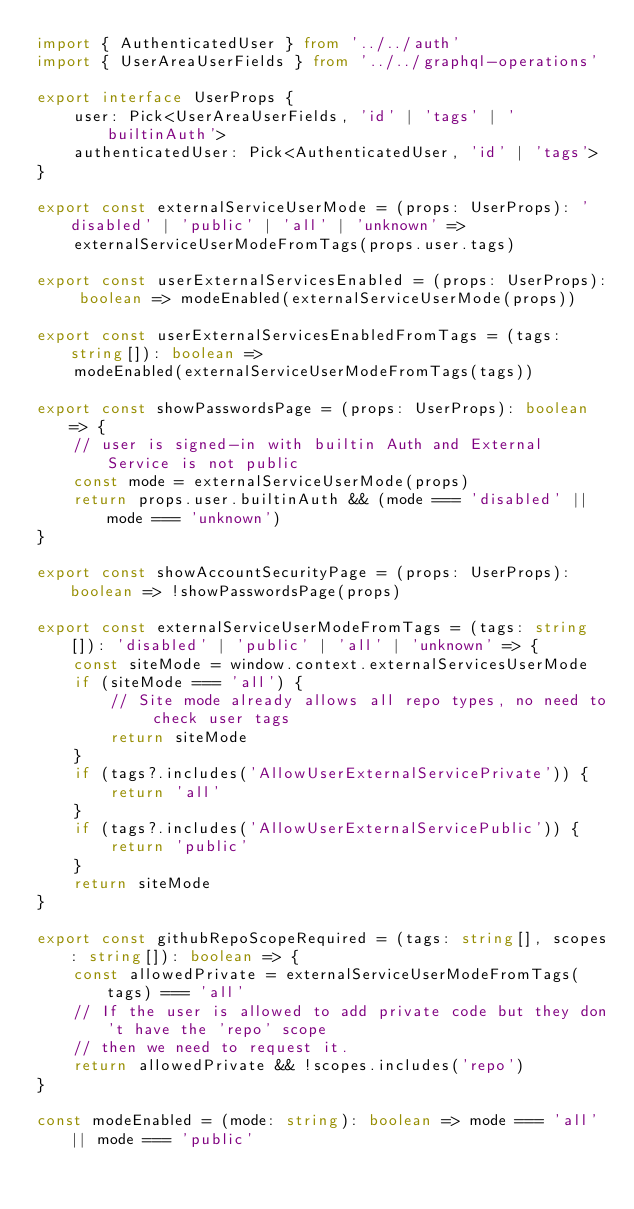Convert code to text. <code><loc_0><loc_0><loc_500><loc_500><_TypeScript_>import { AuthenticatedUser } from '../../auth'
import { UserAreaUserFields } from '../../graphql-operations'

export interface UserProps {
    user: Pick<UserAreaUserFields, 'id' | 'tags' | 'builtinAuth'>
    authenticatedUser: Pick<AuthenticatedUser, 'id' | 'tags'>
}

export const externalServiceUserMode = (props: UserProps): 'disabled' | 'public' | 'all' | 'unknown' =>
    externalServiceUserModeFromTags(props.user.tags)

export const userExternalServicesEnabled = (props: UserProps): boolean => modeEnabled(externalServiceUserMode(props))

export const userExternalServicesEnabledFromTags = (tags: string[]): boolean =>
    modeEnabled(externalServiceUserModeFromTags(tags))

export const showPasswordsPage = (props: UserProps): boolean => {
    // user is signed-in with builtin Auth and External Service is not public
    const mode = externalServiceUserMode(props)
    return props.user.builtinAuth && (mode === 'disabled' || mode === 'unknown')
}

export const showAccountSecurityPage = (props: UserProps): boolean => !showPasswordsPage(props)

export const externalServiceUserModeFromTags = (tags: string[]): 'disabled' | 'public' | 'all' | 'unknown' => {
    const siteMode = window.context.externalServicesUserMode
    if (siteMode === 'all') {
        // Site mode already allows all repo types, no need to check user tags
        return siteMode
    }
    if (tags?.includes('AllowUserExternalServicePrivate')) {
        return 'all'
    }
    if (tags?.includes('AllowUserExternalServicePublic')) {
        return 'public'
    }
    return siteMode
}

export const githubRepoScopeRequired = (tags: string[], scopes: string[]): boolean => {
    const allowedPrivate = externalServiceUserModeFromTags(tags) === 'all'
    // If the user is allowed to add private code but they don't have the 'repo' scope
    // then we need to request it.
    return allowedPrivate && !scopes.includes('repo')
}

const modeEnabled = (mode: string): boolean => mode === 'all' || mode === 'public'
</code> 